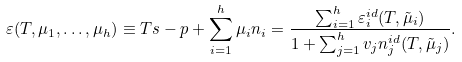Convert formula to latex. <formula><loc_0><loc_0><loc_500><loc_500>\varepsilon ( T , \mu _ { 1 } , \dots , \mu _ { h } ) \equiv T s - p + \sum _ { i = 1 } ^ { h } \mu _ { i } n _ { i } = \frac { \sum _ { i = 1 } ^ { h } \varepsilon _ { i } ^ { i d } ( T , \tilde { \mu } _ { i } ) } { 1 + \sum _ { j = 1 } ^ { h } v _ { j } n _ { j } ^ { i d } ( T , \tilde { \mu } _ { j } ) } .</formula> 